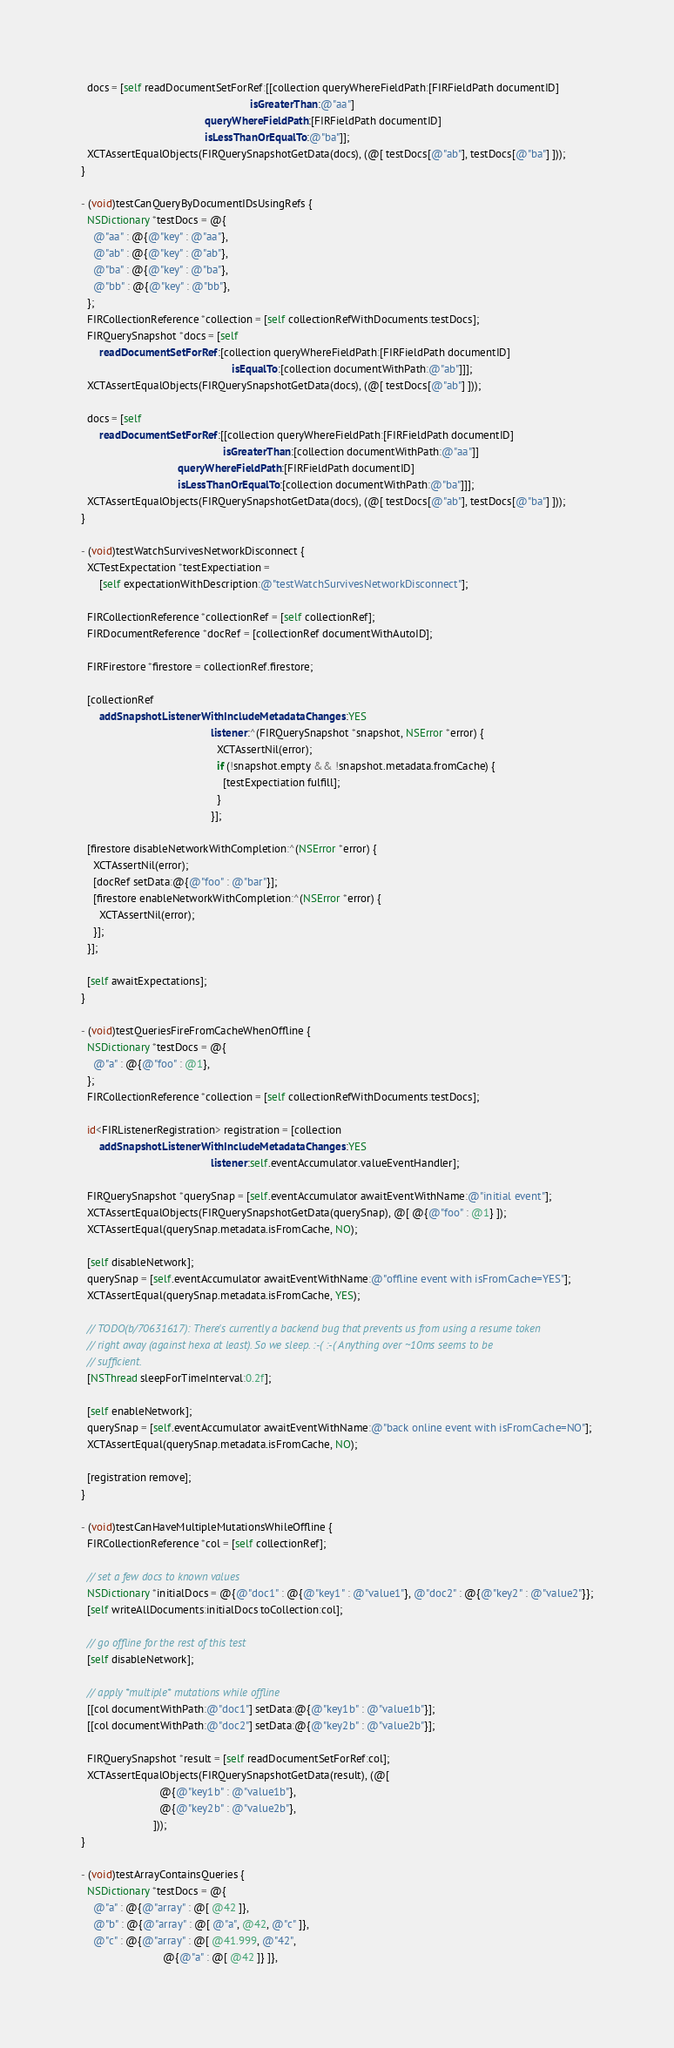Convert code to text. <code><loc_0><loc_0><loc_500><loc_500><_ObjectiveC_>
  docs = [self readDocumentSetForRef:[[collection queryWhereFieldPath:[FIRFieldPath documentID]
                                                        isGreaterThan:@"aa"]
                                         queryWhereFieldPath:[FIRFieldPath documentID]
                                         isLessThanOrEqualTo:@"ba"]];
  XCTAssertEqualObjects(FIRQuerySnapshotGetData(docs), (@[ testDocs[@"ab"], testDocs[@"ba"] ]));
}

- (void)testCanQueryByDocumentIDsUsingRefs {
  NSDictionary *testDocs = @{
    @"aa" : @{@"key" : @"aa"},
    @"ab" : @{@"key" : @"ab"},
    @"ba" : @{@"key" : @"ba"},
    @"bb" : @{@"key" : @"bb"},
  };
  FIRCollectionReference *collection = [self collectionRefWithDocuments:testDocs];
  FIRQuerySnapshot *docs = [self
      readDocumentSetForRef:[collection queryWhereFieldPath:[FIRFieldPath documentID]
                                                  isEqualTo:[collection documentWithPath:@"ab"]]];
  XCTAssertEqualObjects(FIRQuerySnapshotGetData(docs), (@[ testDocs[@"ab"] ]));

  docs = [self
      readDocumentSetForRef:[[collection queryWhereFieldPath:[FIRFieldPath documentID]
                                               isGreaterThan:[collection documentWithPath:@"aa"]]
                                queryWhereFieldPath:[FIRFieldPath documentID]
                                isLessThanOrEqualTo:[collection documentWithPath:@"ba"]]];
  XCTAssertEqualObjects(FIRQuerySnapshotGetData(docs), (@[ testDocs[@"ab"], testDocs[@"ba"] ]));
}

- (void)testWatchSurvivesNetworkDisconnect {
  XCTestExpectation *testExpectiation =
      [self expectationWithDescription:@"testWatchSurvivesNetworkDisconnect"];

  FIRCollectionReference *collectionRef = [self collectionRef];
  FIRDocumentReference *docRef = [collectionRef documentWithAutoID];

  FIRFirestore *firestore = collectionRef.firestore;

  [collectionRef
      addSnapshotListenerWithIncludeMetadataChanges:YES
                                           listener:^(FIRQuerySnapshot *snapshot, NSError *error) {
                                             XCTAssertNil(error);
                                             if (!snapshot.empty && !snapshot.metadata.fromCache) {
                                               [testExpectiation fulfill];
                                             }
                                           }];

  [firestore disableNetworkWithCompletion:^(NSError *error) {
    XCTAssertNil(error);
    [docRef setData:@{@"foo" : @"bar"}];
    [firestore enableNetworkWithCompletion:^(NSError *error) {
      XCTAssertNil(error);
    }];
  }];

  [self awaitExpectations];
}

- (void)testQueriesFireFromCacheWhenOffline {
  NSDictionary *testDocs = @{
    @"a" : @{@"foo" : @1},
  };
  FIRCollectionReference *collection = [self collectionRefWithDocuments:testDocs];

  id<FIRListenerRegistration> registration = [collection
      addSnapshotListenerWithIncludeMetadataChanges:YES
                                           listener:self.eventAccumulator.valueEventHandler];

  FIRQuerySnapshot *querySnap = [self.eventAccumulator awaitEventWithName:@"initial event"];
  XCTAssertEqualObjects(FIRQuerySnapshotGetData(querySnap), @[ @{@"foo" : @1} ]);
  XCTAssertEqual(querySnap.metadata.isFromCache, NO);

  [self disableNetwork];
  querySnap = [self.eventAccumulator awaitEventWithName:@"offline event with isFromCache=YES"];
  XCTAssertEqual(querySnap.metadata.isFromCache, YES);

  // TODO(b/70631617): There's currently a backend bug that prevents us from using a resume token
  // right away (against hexa at least). So we sleep. :-( :-( Anything over ~10ms seems to be
  // sufficient.
  [NSThread sleepForTimeInterval:0.2f];

  [self enableNetwork];
  querySnap = [self.eventAccumulator awaitEventWithName:@"back online event with isFromCache=NO"];
  XCTAssertEqual(querySnap.metadata.isFromCache, NO);

  [registration remove];
}

- (void)testCanHaveMultipleMutationsWhileOffline {
  FIRCollectionReference *col = [self collectionRef];

  // set a few docs to known values
  NSDictionary *initialDocs = @{@"doc1" : @{@"key1" : @"value1"}, @"doc2" : @{@"key2" : @"value2"}};
  [self writeAllDocuments:initialDocs toCollection:col];

  // go offline for the rest of this test
  [self disableNetwork];

  // apply *multiple* mutations while offline
  [[col documentWithPath:@"doc1"] setData:@{@"key1b" : @"value1b"}];
  [[col documentWithPath:@"doc2"] setData:@{@"key2b" : @"value2b"}];

  FIRQuerySnapshot *result = [self readDocumentSetForRef:col];
  XCTAssertEqualObjects(FIRQuerySnapshotGetData(result), (@[
                          @{@"key1b" : @"value1b"},
                          @{@"key2b" : @"value2b"},
                        ]));
}

- (void)testArrayContainsQueries {
  NSDictionary *testDocs = @{
    @"a" : @{@"array" : @[ @42 ]},
    @"b" : @{@"array" : @[ @"a", @42, @"c" ]},
    @"c" : @{@"array" : @[ @41.999, @"42",
                           @{@"a" : @[ @42 ]} ]},</code> 